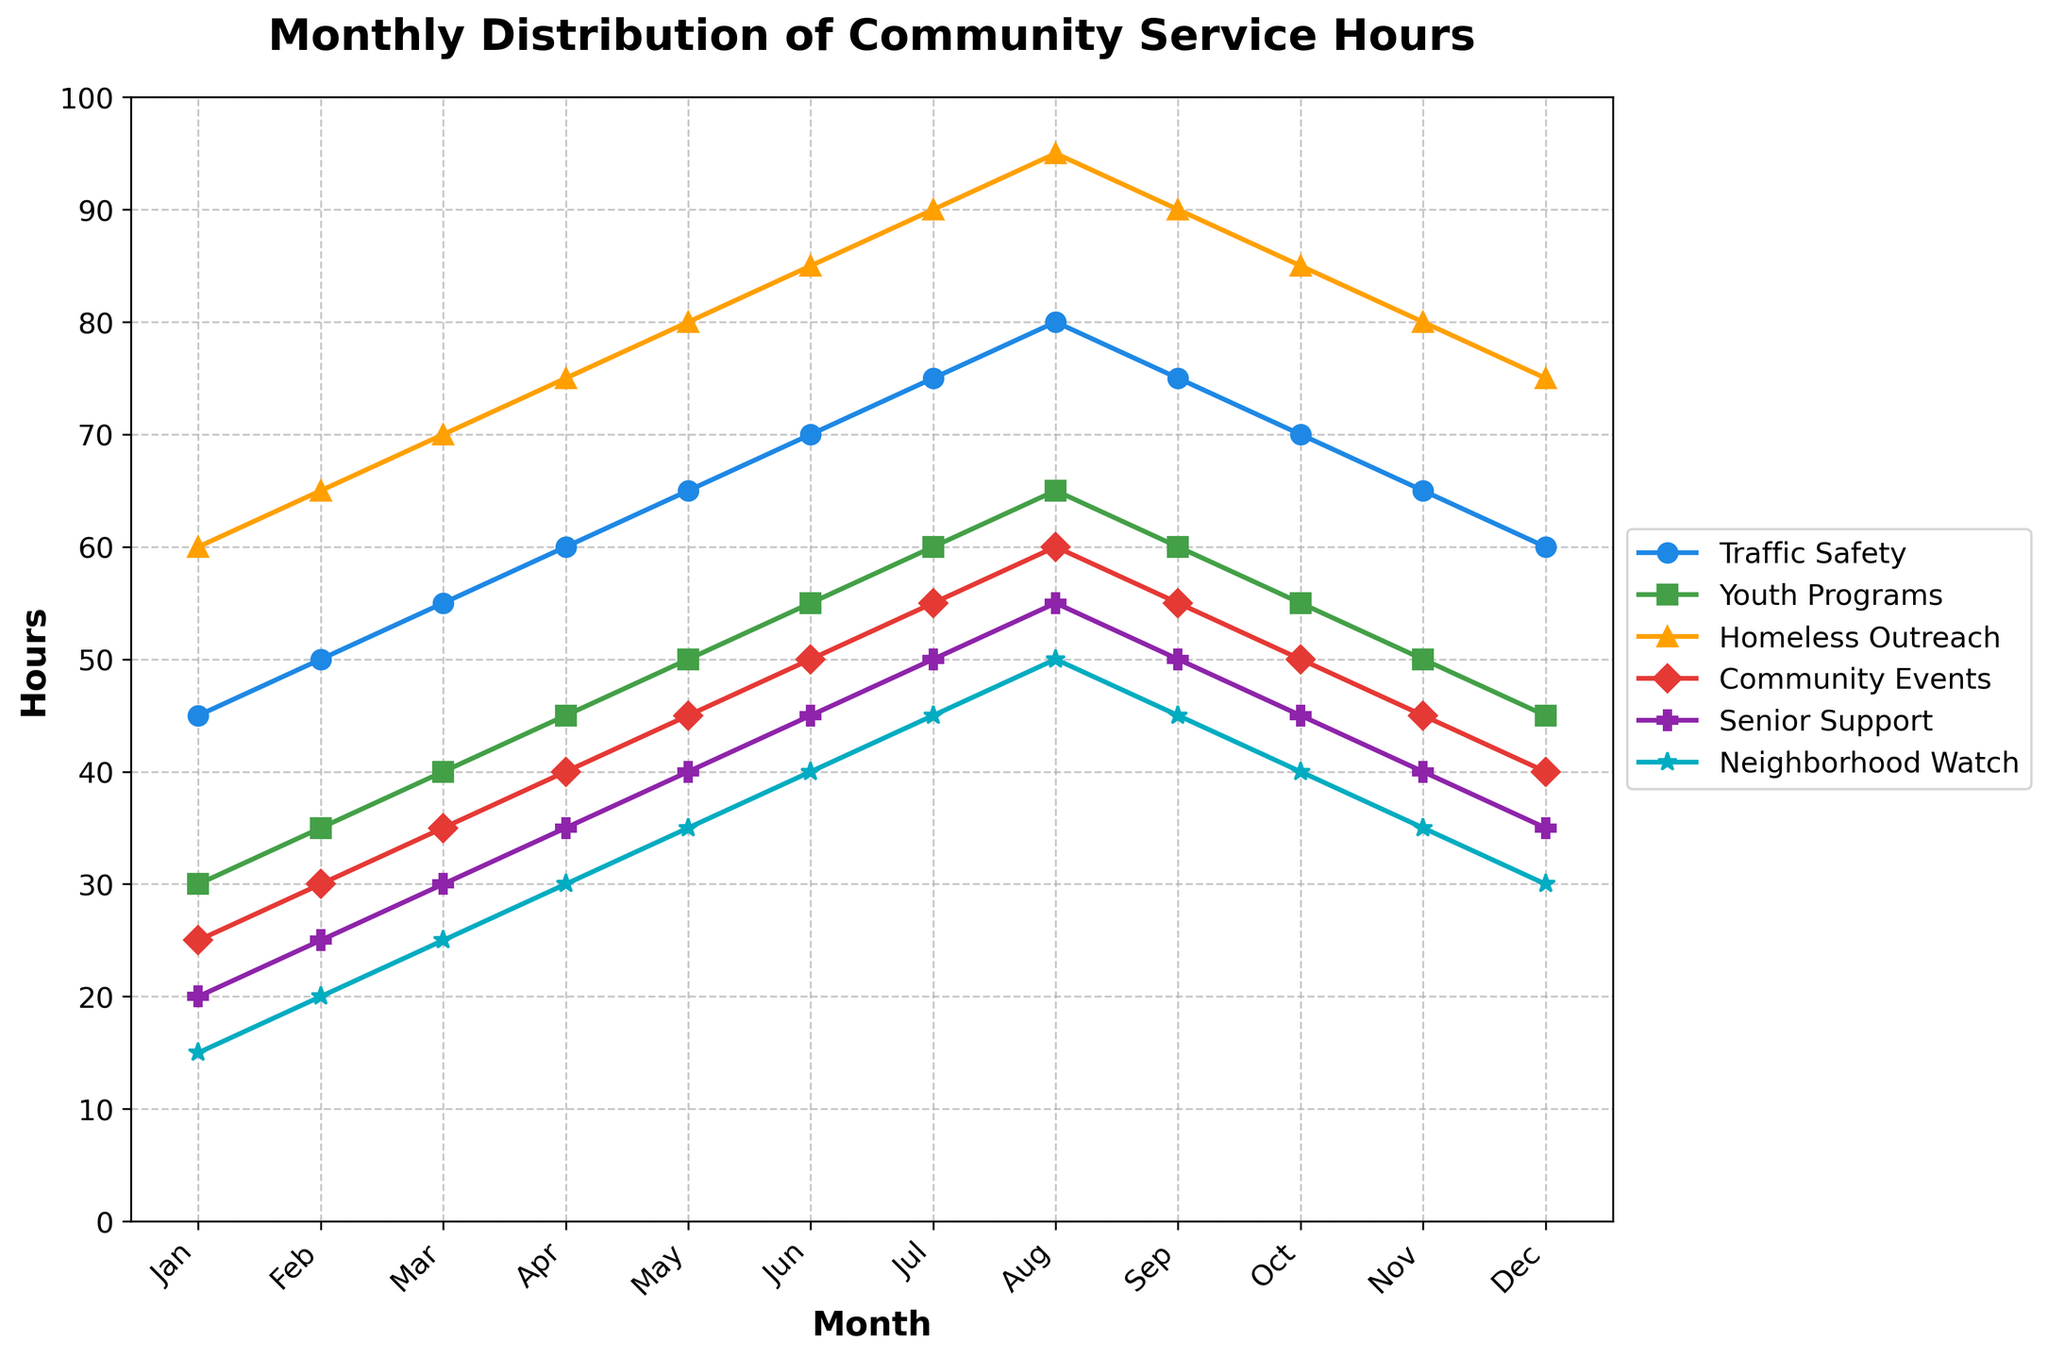What month had the highest number of hours for Homeless Outreach? To find the month with the highest number of hours for Homeless Outreach, look at the data points for Homeless Outreach in each month. August has the highest value of 95 hours for Homeless Outreach.
Answer: August In which month did Youth Programs have hours equal to Senior Support? Compare the values for Youth Programs and Senior Support across all months until you find one where they are the same. In May, both Youth Programs and Senior Support have 50 hours.
Answer: May Which service had the highest increase in hours from January to December? Calculate the change in hours from January to December for each service: Traffic Safety (60-45), Youth Programs (45-30), Homeless Outreach (75-60), Community Events (40-25), Senior Support (35-20), Neighborhood Watch (30-15). The largest increase is in Traffic Safety with a 15-hour increase.
Answer: Traffic Safety What is the average number of monthly service hours for Community Events over the year? Add up the hours for Community Events from January to December (25 + 30 + 35 + 40 + 45 + 50 + 55 + 60 + 55 + 50 + 45 + 40) which equals 530. Then, divide by the number of months (12). 530/12 = approximately 44.17 hours.
Answer: 44.17 hours From July to August, which service showed the biggest percentage increase in hours? Calculate the percentage increase for each service from July to August using the formula: ((August Hours - July Hours) / July Hours) * 100. Traffic Safety: ((80-75)/75)*100 = 6.67%. Youth Programs: ((65-60)/60)*100 = 8.33%. Homeless Outreach: ((95-90)/90)*100 = 5.56%. Community Events: ((60-55)/55)*100 = 9.09%. Senior Support: ((55-50)/50)*100 = 10%. Neighborhood Watch: ((50-45)/45)*100 = 11.11%. The biggest percentage increase is in Neighborhood Watch with 11.11%.
Answer: Neighborhood Watch Which months have a consistent pattern of increase in hours for Traffic Safety over the year? Analyze the data for Traffic Safety month by month. The hours increase consistently from January to August (45, 50, 55, 60, 65, 70, 75, 80) and then decrease.
Answer: January to August How much did the total hours for Neighborhood Watch decrease from August to December? Calculate the difference in hours from August to December for Neighborhood Watch: August (50) - December (30) = 20 hours decrease.
Answer: 20 hours Does Senior Support ever reach hours equal to 50 in the year? Look at the data points for Senior Support across all months. In May, Senior Support has exactly 50 hours.
Answer: Yes 